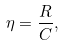<formula> <loc_0><loc_0><loc_500><loc_500>\eta = \frac { R } { C } ,</formula> 